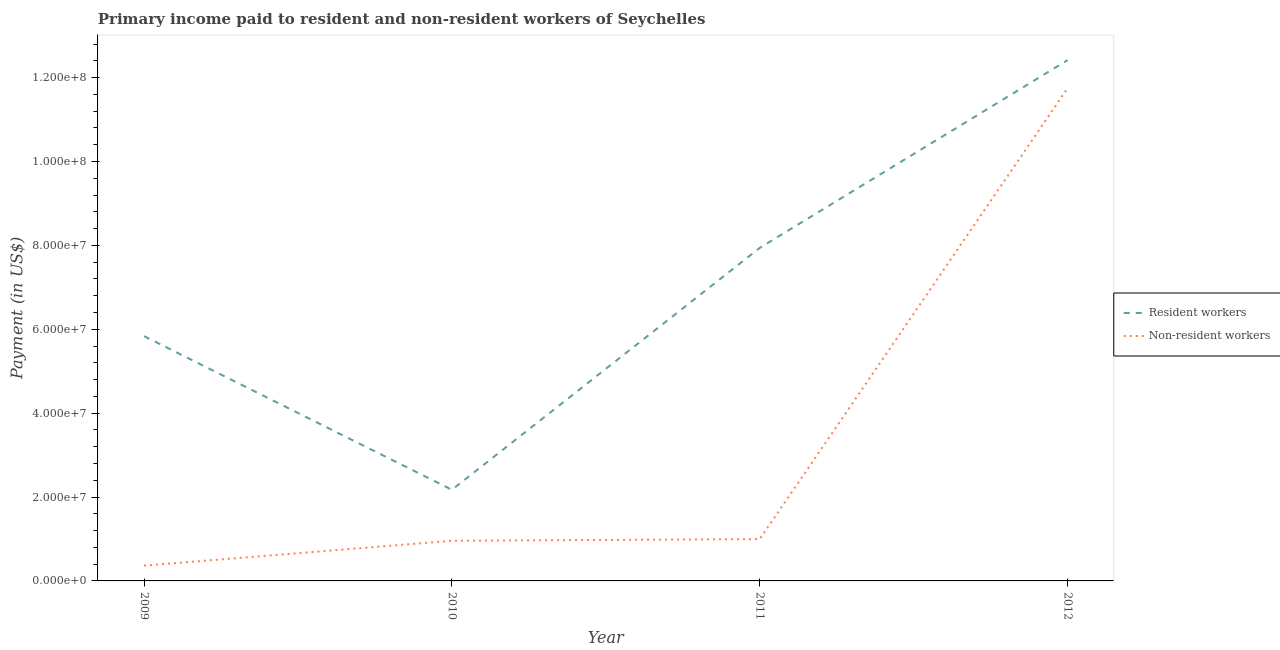How many different coloured lines are there?
Provide a succinct answer. 2. What is the payment made to non-resident workers in 2010?
Your response must be concise. 9.57e+06. Across all years, what is the maximum payment made to non-resident workers?
Offer a terse response. 1.17e+08. Across all years, what is the minimum payment made to non-resident workers?
Keep it short and to the point. 3.65e+06. In which year was the payment made to resident workers maximum?
Offer a terse response. 2012. In which year was the payment made to resident workers minimum?
Provide a short and direct response. 2010. What is the total payment made to non-resident workers in the graph?
Provide a short and direct response. 1.41e+08. What is the difference between the payment made to resident workers in 2009 and that in 2011?
Keep it short and to the point. -2.10e+07. What is the difference between the payment made to resident workers in 2012 and the payment made to non-resident workers in 2010?
Provide a succinct answer. 1.15e+08. What is the average payment made to non-resident workers per year?
Offer a terse response. 3.52e+07. In the year 2011, what is the difference between the payment made to non-resident workers and payment made to resident workers?
Your answer should be very brief. -6.94e+07. In how many years, is the payment made to resident workers greater than 88000000 US$?
Provide a short and direct response. 1. What is the ratio of the payment made to non-resident workers in 2009 to that in 2012?
Your response must be concise. 0.03. Is the payment made to non-resident workers in 2009 less than that in 2010?
Your answer should be very brief. Yes. What is the difference between the highest and the second highest payment made to non-resident workers?
Keep it short and to the point. 1.07e+08. What is the difference between the highest and the lowest payment made to resident workers?
Your answer should be very brief. 1.02e+08. In how many years, is the payment made to resident workers greater than the average payment made to resident workers taken over all years?
Provide a short and direct response. 2. How many lines are there?
Give a very brief answer. 2. How many years are there in the graph?
Your response must be concise. 4. Does the graph contain grids?
Ensure brevity in your answer.  No. What is the title of the graph?
Provide a short and direct response. Primary income paid to resident and non-resident workers of Seychelles. Does "Time to export" appear as one of the legend labels in the graph?
Your answer should be compact. No. What is the label or title of the X-axis?
Provide a short and direct response. Year. What is the label or title of the Y-axis?
Provide a short and direct response. Payment (in US$). What is the Payment (in US$) of Resident workers in 2009?
Your answer should be very brief. 5.84e+07. What is the Payment (in US$) of Non-resident workers in 2009?
Your response must be concise. 3.65e+06. What is the Payment (in US$) of Resident workers in 2010?
Ensure brevity in your answer.  2.17e+07. What is the Payment (in US$) of Non-resident workers in 2010?
Your answer should be compact. 9.57e+06. What is the Payment (in US$) of Resident workers in 2011?
Make the answer very short. 7.94e+07. What is the Payment (in US$) in Non-resident workers in 2011?
Your answer should be compact. 9.97e+06. What is the Payment (in US$) in Resident workers in 2012?
Make the answer very short. 1.24e+08. What is the Payment (in US$) in Non-resident workers in 2012?
Your answer should be compact. 1.17e+08. Across all years, what is the maximum Payment (in US$) in Resident workers?
Give a very brief answer. 1.24e+08. Across all years, what is the maximum Payment (in US$) of Non-resident workers?
Make the answer very short. 1.17e+08. Across all years, what is the minimum Payment (in US$) of Resident workers?
Give a very brief answer. 2.17e+07. Across all years, what is the minimum Payment (in US$) in Non-resident workers?
Your response must be concise. 3.65e+06. What is the total Payment (in US$) of Resident workers in the graph?
Provide a succinct answer. 2.84e+08. What is the total Payment (in US$) of Non-resident workers in the graph?
Offer a terse response. 1.41e+08. What is the difference between the Payment (in US$) of Resident workers in 2009 and that in 2010?
Make the answer very short. 3.66e+07. What is the difference between the Payment (in US$) in Non-resident workers in 2009 and that in 2010?
Provide a succinct answer. -5.92e+06. What is the difference between the Payment (in US$) of Resident workers in 2009 and that in 2011?
Your response must be concise. -2.10e+07. What is the difference between the Payment (in US$) in Non-resident workers in 2009 and that in 2011?
Give a very brief answer. -6.32e+06. What is the difference between the Payment (in US$) in Resident workers in 2009 and that in 2012?
Provide a short and direct response. -6.58e+07. What is the difference between the Payment (in US$) of Non-resident workers in 2009 and that in 2012?
Give a very brief answer. -1.14e+08. What is the difference between the Payment (in US$) of Resident workers in 2010 and that in 2011?
Your answer should be compact. -5.77e+07. What is the difference between the Payment (in US$) of Non-resident workers in 2010 and that in 2011?
Your answer should be very brief. -4.01e+05. What is the difference between the Payment (in US$) in Resident workers in 2010 and that in 2012?
Make the answer very short. -1.02e+08. What is the difference between the Payment (in US$) of Non-resident workers in 2010 and that in 2012?
Ensure brevity in your answer.  -1.08e+08. What is the difference between the Payment (in US$) of Resident workers in 2011 and that in 2012?
Keep it short and to the point. -4.48e+07. What is the difference between the Payment (in US$) of Non-resident workers in 2011 and that in 2012?
Offer a very short reply. -1.07e+08. What is the difference between the Payment (in US$) of Resident workers in 2009 and the Payment (in US$) of Non-resident workers in 2010?
Ensure brevity in your answer.  4.88e+07. What is the difference between the Payment (in US$) of Resident workers in 2009 and the Payment (in US$) of Non-resident workers in 2011?
Provide a short and direct response. 4.84e+07. What is the difference between the Payment (in US$) in Resident workers in 2009 and the Payment (in US$) in Non-resident workers in 2012?
Provide a short and direct response. -5.91e+07. What is the difference between the Payment (in US$) in Resident workers in 2010 and the Payment (in US$) in Non-resident workers in 2011?
Provide a short and direct response. 1.18e+07. What is the difference between the Payment (in US$) in Resident workers in 2010 and the Payment (in US$) in Non-resident workers in 2012?
Your answer should be compact. -9.57e+07. What is the difference between the Payment (in US$) of Resident workers in 2011 and the Payment (in US$) of Non-resident workers in 2012?
Your response must be concise. -3.81e+07. What is the average Payment (in US$) of Resident workers per year?
Your answer should be very brief. 7.09e+07. What is the average Payment (in US$) of Non-resident workers per year?
Provide a succinct answer. 3.52e+07. In the year 2009, what is the difference between the Payment (in US$) of Resident workers and Payment (in US$) of Non-resident workers?
Make the answer very short. 5.47e+07. In the year 2010, what is the difference between the Payment (in US$) in Resident workers and Payment (in US$) in Non-resident workers?
Offer a terse response. 1.22e+07. In the year 2011, what is the difference between the Payment (in US$) of Resident workers and Payment (in US$) of Non-resident workers?
Ensure brevity in your answer.  6.94e+07. In the year 2012, what is the difference between the Payment (in US$) of Resident workers and Payment (in US$) of Non-resident workers?
Provide a succinct answer. 6.70e+06. What is the ratio of the Payment (in US$) of Resident workers in 2009 to that in 2010?
Offer a very short reply. 2.69. What is the ratio of the Payment (in US$) in Non-resident workers in 2009 to that in 2010?
Offer a terse response. 0.38. What is the ratio of the Payment (in US$) in Resident workers in 2009 to that in 2011?
Offer a very short reply. 0.73. What is the ratio of the Payment (in US$) of Non-resident workers in 2009 to that in 2011?
Give a very brief answer. 0.37. What is the ratio of the Payment (in US$) of Resident workers in 2009 to that in 2012?
Make the answer very short. 0.47. What is the ratio of the Payment (in US$) in Non-resident workers in 2009 to that in 2012?
Provide a succinct answer. 0.03. What is the ratio of the Payment (in US$) in Resident workers in 2010 to that in 2011?
Provide a short and direct response. 0.27. What is the ratio of the Payment (in US$) of Non-resident workers in 2010 to that in 2011?
Give a very brief answer. 0.96. What is the ratio of the Payment (in US$) of Resident workers in 2010 to that in 2012?
Keep it short and to the point. 0.17. What is the ratio of the Payment (in US$) of Non-resident workers in 2010 to that in 2012?
Provide a short and direct response. 0.08. What is the ratio of the Payment (in US$) of Resident workers in 2011 to that in 2012?
Your response must be concise. 0.64. What is the ratio of the Payment (in US$) of Non-resident workers in 2011 to that in 2012?
Provide a succinct answer. 0.08. What is the difference between the highest and the second highest Payment (in US$) of Resident workers?
Provide a short and direct response. 4.48e+07. What is the difference between the highest and the second highest Payment (in US$) in Non-resident workers?
Provide a succinct answer. 1.07e+08. What is the difference between the highest and the lowest Payment (in US$) in Resident workers?
Provide a succinct answer. 1.02e+08. What is the difference between the highest and the lowest Payment (in US$) of Non-resident workers?
Provide a short and direct response. 1.14e+08. 